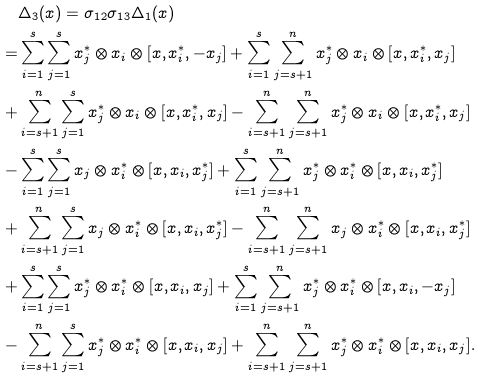<formula> <loc_0><loc_0><loc_500><loc_500>& \Delta _ { 3 } ( x ) = \sigma _ { 1 2 } \sigma _ { 1 3 } \Delta _ { 1 } ( x ) \\ = & \sum _ { i = 1 } ^ { s } \sum _ { j = 1 } ^ { s } x _ { j } ^ { * } \otimes x _ { i } \otimes [ x , x _ { i } ^ { * } , - x _ { j } ] + \sum _ { i = 1 } ^ { s } \sum _ { j = s + 1 } ^ { n } x _ { j } ^ { * } \otimes x _ { i } \otimes [ x , x _ { i } ^ { * } , x _ { j } ] \\ + & \sum _ { i = s + 1 } ^ { n } \sum _ { j = 1 } ^ { s } x _ { j } ^ { * } \otimes x _ { i } \otimes [ x , x _ { i } ^ { * } , x _ { j } ] - \sum _ { i = s + 1 } ^ { n } \sum _ { j = s + 1 } ^ { n } x _ { j } ^ { * } \otimes x _ { i } \otimes [ x , x _ { i } ^ { * } , x _ { j } ] \\ - & \sum _ { i = 1 } ^ { s } \sum _ { j = 1 } ^ { s } x _ { j } \otimes x _ { i } ^ { * } \otimes [ x , x _ { i } , x _ { j } ^ { * } ] + \sum _ { i = 1 } ^ { s } \sum _ { j = s + 1 } ^ { n } x _ { j } ^ { * } \otimes x _ { i } ^ { * } \otimes [ x , x _ { i } , x _ { j } ^ { * } ] \\ + & \sum _ { i = s + 1 } ^ { n } \sum _ { j = 1 } ^ { s } x _ { j } \otimes x _ { i } ^ { * } \otimes [ x , x _ { i } , x _ { j } ^ { * } ] - \sum _ { i = s + 1 } ^ { n } \sum _ { j = s + 1 } ^ { n } x _ { j } \otimes x _ { i } ^ { * } \otimes [ x , x _ { i } , x _ { j } ^ { * } ] \\ + & \sum _ { i = 1 } ^ { s } \sum _ { j = 1 } ^ { s } x _ { j } ^ { * } \otimes x _ { i } ^ { * } \otimes [ x , x _ { i } , x _ { j } ] + \sum _ { i = 1 } ^ { s } \sum _ { j = s + 1 } ^ { n } x _ { j } ^ { * } \otimes x _ { i } ^ { * } \otimes [ x , x _ { i } , - x _ { j } ] \\ - & \sum _ { i = s + 1 } ^ { n } \sum _ { j = 1 } ^ { s } x _ { j } ^ { * } \otimes x _ { i } ^ { * } \otimes [ x , x _ { i } , x _ { j } ] + \sum _ { i = s + 1 } ^ { n } \sum _ { j = s + 1 } ^ { n } x _ { j } ^ { * } \otimes x _ { i } ^ { * } \otimes [ x , x _ { i } , x _ { j } ] . \\</formula> 